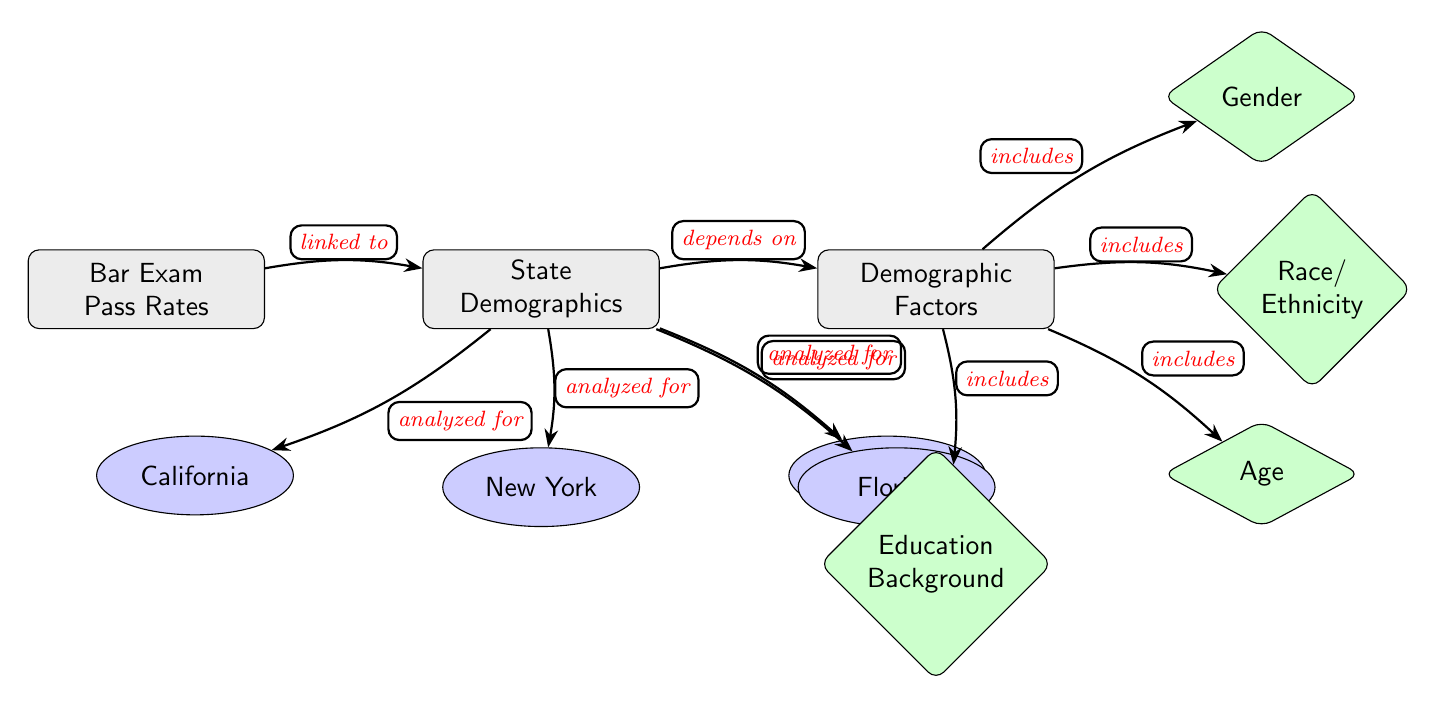What factors are included in analyzing state demographics? The diagram shows that the demographic factors analyzed include gender, race/ethnicity, age, and education background. This information can be found in the section labeled "Demographic Factors" connected to the "State Demographics."
Answer: Gender, Race/Ethnicity, Age, Education Background How many states are analyzed in the diagram? In the diagram, four specific states are indicated: California, New York, Texas, and Florida. These states are represented as nodes that are directly connected to the "State Demographics" node.
Answer: Four What is the main subject of the diagram? The central focus of the diagram is represented by the node labeled "Bar Exam Pass Rates." This is the primary concept that all other nodes relate to.
Answer: Bar Exam Pass Rates Which state is positioned below left of 'State Demographics'? According to the layout of the diagram, California is the state node that is positioned below left of the "State Demographics" node. This spatial relationship in the diagram defines its location.
Answer: California How does the demographic analysis connect to the bar exam pass rates? There is a direct connection indicated by the labeled edge "linked to" from "Bar Exam Pass Rates" to "State Demographics." This signifies that the analysis of state demographics has a direct impact or correlation with pass rates.
Answer: Linked to What does the term 'depends on' connect to in the diagram? The term 'depends on' in the diagram connects "State Demographics" to "Demographic Factors." This relationship indicates that the analysis of demographics is shaped by these specific factors.
Answer: Demographic Factors Which demographic factor is located at the bottom right of the 'Demographic Factors'? The demographic factor that is represented at the bottom right of the "Demographic Factors" node in the diagram is "Education Background," as visually represented in the spatial arrangement.
Answer: Education Background What is the relationship between 'State Demographics' and 'Bar Exam Pass Rates'? The relationship is indicated by the edge labeled "linked to," demonstrating that the state demographics have an influence or direct connection to the bar exam pass rates, which is the focus of the diagram.
Answer: Linked to 